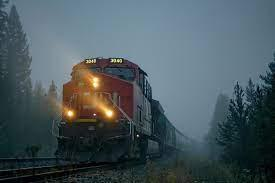In which region or type of landscape does this train appear to be traveling? The train appears to be traveling through a densely wooded area, likely situated in a mountainous or hilly region given the presence of mist, which is common in higher elevations or areas with large temperature fluctuations. What emotions does this image evoke, and why might someone photograph a scene like this? This image evokes a sense of wanderlust and reflection. The juxtaposition of the powerful locomotive with the serene, foggy backdrop might inspire thoughts about the journey's importance over the destination. A photographer might capture this scene to convey the peaceful coexistence between technology and nature or to portray the quiet moments of travel often overlooked in our fast-paced world. 